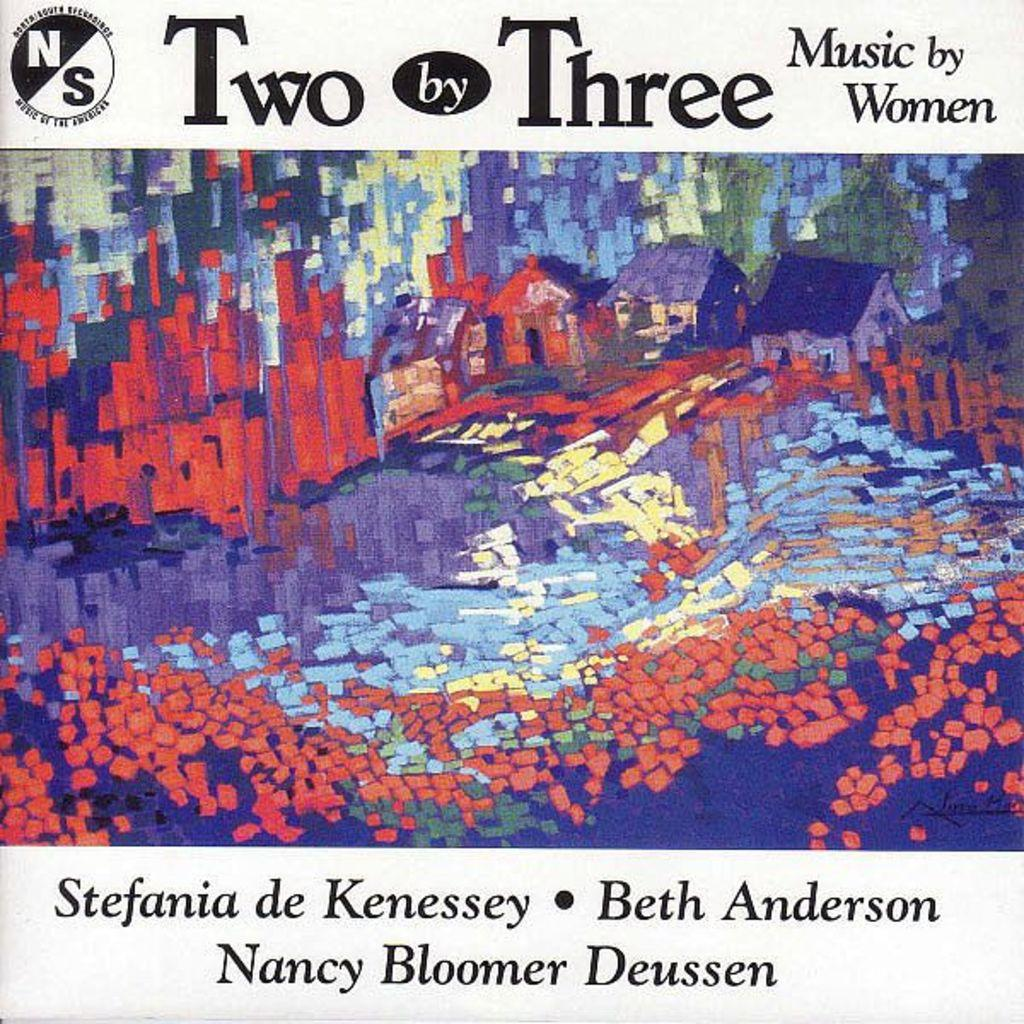<image>
Share a concise interpretation of the image provided. The cover of Two by Three an album of music by Women. 